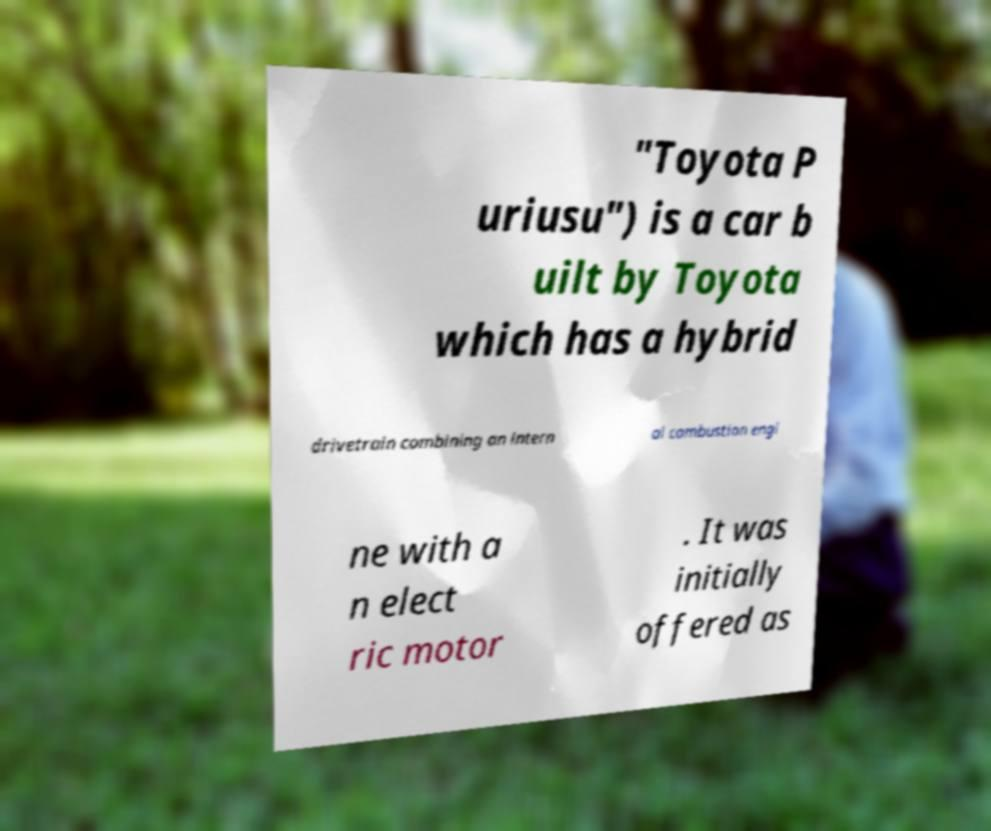There's text embedded in this image that I need extracted. Can you transcribe it verbatim? "Toyota P uriusu") is a car b uilt by Toyota which has a hybrid drivetrain combining an intern al combustion engi ne with a n elect ric motor . It was initially offered as 